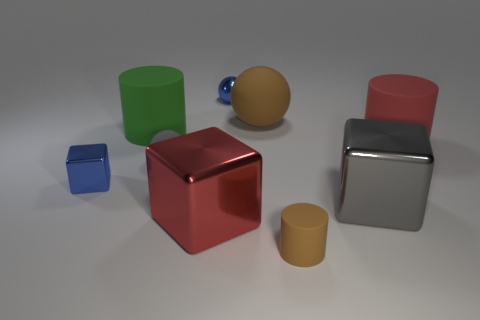What is the material of the tiny sphere that is the same color as the tiny shiny cube?
Keep it short and to the point. Metal. Is there anything else that has the same size as the red matte object?
Your answer should be compact. Yes. How many other things are there of the same shape as the big red matte object?
Offer a terse response. 2. Do the green thing behind the small gray ball and the red cube have the same material?
Provide a short and direct response. No. Is the number of big brown things that are to the left of the brown cylinder the same as the number of red blocks in front of the shiny sphere?
Provide a succinct answer. Yes. There is a blue metallic object that is on the right side of the large green thing; what size is it?
Make the answer very short. Small. Is there a large brown object made of the same material as the brown cylinder?
Give a very brief answer. Yes. Does the tiny matte thing that is behind the tiny brown thing have the same color as the big rubber ball?
Offer a terse response. No. Are there an equal number of tiny blue balls in front of the big red rubber cylinder and purple shiny balls?
Provide a succinct answer. Yes. Is there a block that has the same color as the small metallic sphere?
Ensure brevity in your answer.  Yes. 